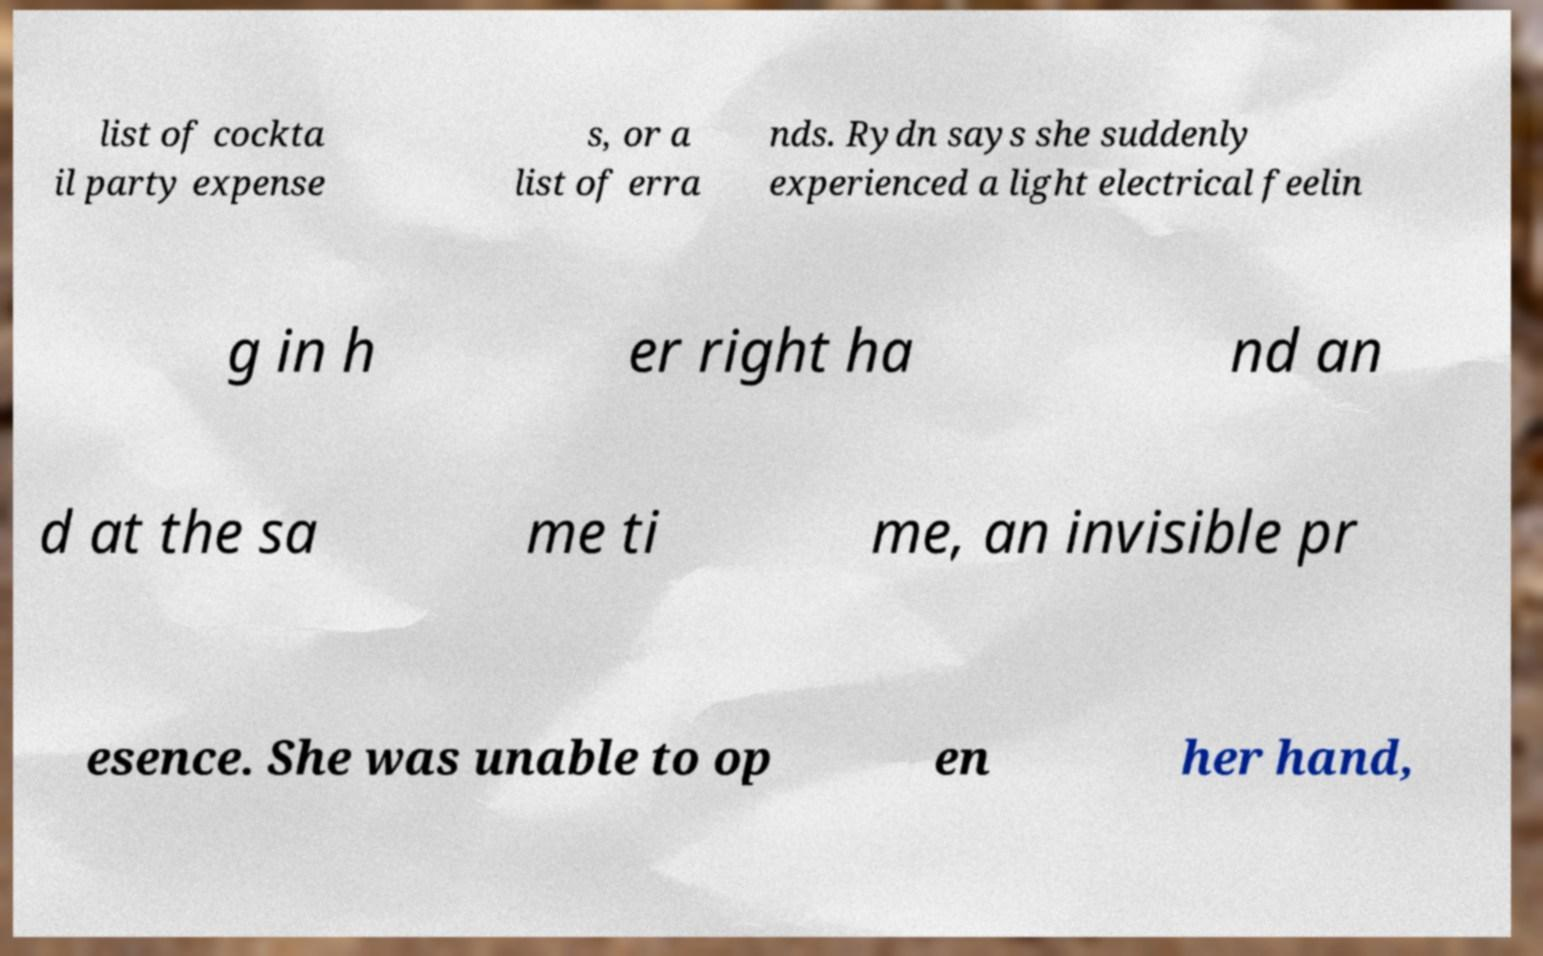Could you assist in decoding the text presented in this image and type it out clearly? list of cockta il party expense s, or a list of erra nds. Rydn says she suddenly experienced a light electrical feelin g in h er right ha nd an d at the sa me ti me, an invisible pr esence. She was unable to op en her hand, 